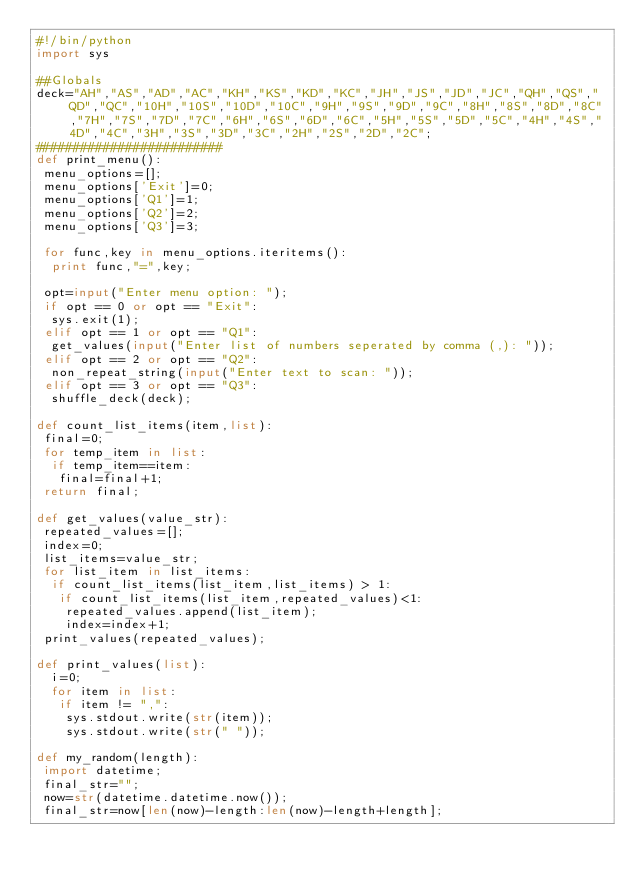<code> <loc_0><loc_0><loc_500><loc_500><_Python_>#!/bin/python
import sys

##Globals
deck="AH","AS","AD","AC","KH","KS","KD","KC","JH","JS","JD","JC","QH","QS","QD","QC","10H","10S","10D","10C","9H","9S","9D","9C","8H","8S","8D","8C","7H","7S","7D","7C","6H","6S","6D","6C","5H","5S","5D","5C","4H","4S","4D","4C","3H","3S","3D","3C","2H","2S","2D","2C";
#########################
def print_menu():
 menu_options=[];
 menu_options['Exit']=0;
 menu_options['Q1']=1;
 menu_options['Q2']=2;
 menu_options['Q3']=3;

 for func,key in menu_options.iteritems():
  print func,"=",key;

 opt=input("Enter menu option: ");
 if opt == 0 or opt == "Exit":
  sys.exit(1);
 elif opt == 1 or opt == "Q1":
  get_values(input("Enter list of numbers seperated by comma (,): "));
 elif opt == 2 or opt == "Q2":
  non_repeat_string(input("Enter text to scan: "));
 elif opt == 3 or opt == "Q3":
  shuffle_deck(deck);

def count_list_items(item,list):
 final=0;
 for temp_item in list:
  if temp_item==item:
   final=final+1;
 return final;

def get_values(value_str):
 repeated_values=[];
 index=0;
 list_items=value_str;
 for list_item in list_items:
  if count_list_items(list_item,list_items) > 1:
   if count_list_items(list_item,repeated_values)<1:
    repeated_values.append(list_item);
    index=index+1;
 print_values(repeated_values);

def print_values(list):
  i=0;
  for item in list:
   if item != ",":
    sys.stdout.write(str(item));
    sys.stdout.write(str(" "));

def my_random(length):
 import datetime;
 final_str="";
 now=str(datetime.datetime.now());
 final_str=now[len(now)-length:len(now)-length+length];</code> 